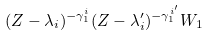Convert formula to latex. <formula><loc_0><loc_0><loc_500><loc_500>( Z - \lambda _ { i } ) ^ { - \gamma _ { 1 } ^ { i } } ( Z - \lambda _ { i } ^ { \prime } ) ^ { - \gamma _ { 1 } ^ { i ^ { \prime } } } W _ { 1 }</formula> 